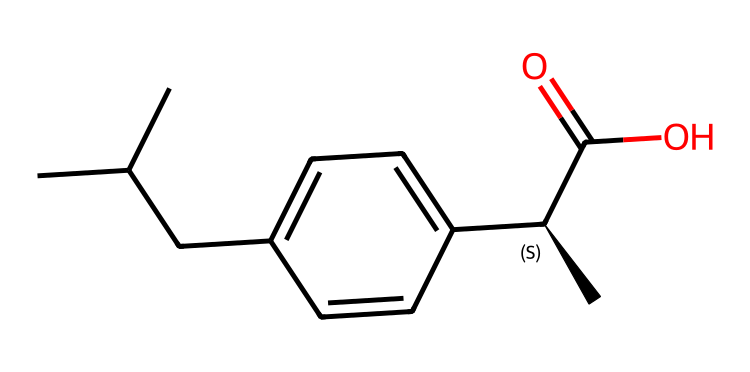What is the molecular formula of ibuprofen? To determine the molecular formula, count the number of carbon (C), hydrogen (H), and oxygen (O) atoms in the provided SMILES representation. The structure shows 13 carbons, 18 hydrogens, and 2 oxygens. These counts translate to the molecular formula C13H18O2.
Answer: C13H18O2 How many chiral centers are present in ibuprofen? A chiral center is usually indicated by the presence of a carbon atom that has four different substituents. In the SMILES for ibuprofen, the '@' symbol denotes a chiral center, and there is one '@' indicating one chiral center in the structure.
Answer: one What type of medicinal compound is ibuprofen classified as? Ibuprofen is classified as a nonsteroidal anti-inflammatory drug (NSAID) due to its mechanism of action, which involves inhibiting enzymes involved in inflammation and pain signaling.
Answer: anti-inflammatory Which functional group is represented by the C(=O)O portion of the molecule? The C(=O)O portion of the SMILES corresponds to a carboxylic acid functional group, which is characterized by a carbon atom double-bonded to an oxygen atom and single-bonded to a hydroxyl group (-OH).
Answer: carboxylic acid What is the total number of rings in ibuprofen’s structure? Upon examining the structure, it is apparent that there are no rings present. The absence of any cyclic components can be confirmed by analyzing the connectivity of the atoms in the SMILES.
Answer: zero How many hydrogen atoms are attached to the benzene ring in ibuprofen? The benzene ring is represented as part of the chemical structure in the SMILES notation. In the case of ibuprofen, it is evident that there are five hydrogen atoms directly attached to the benzene ring, which is a typical saturation for a monosubstituted benzene.
Answer: five 